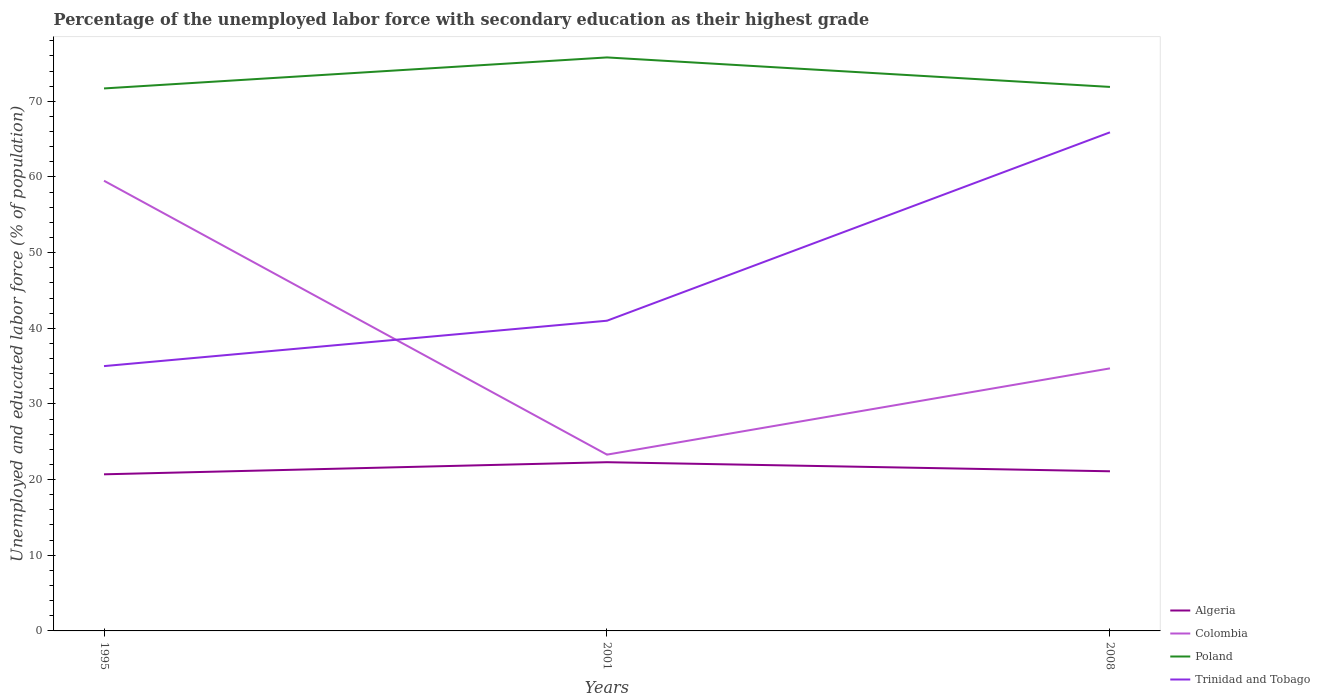Across all years, what is the maximum percentage of the unemployed labor force with secondary education in Colombia?
Give a very brief answer. 23.3. What is the total percentage of the unemployed labor force with secondary education in Trinidad and Tobago in the graph?
Ensure brevity in your answer.  -24.9. What is the difference between the highest and the second highest percentage of the unemployed labor force with secondary education in Colombia?
Provide a short and direct response. 36.2. Are the values on the major ticks of Y-axis written in scientific E-notation?
Your answer should be compact. No. Does the graph contain any zero values?
Offer a terse response. No. Does the graph contain grids?
Offer a terse response. No. Where does the legend appear in the graph?
Make the answer very short. Bottom right. How many legend labels are there?
Ensure brevity in your answer.  4. What is the title of the graph?
Give a very brief answer. Percentage of the unemployed labor force with secondary education as their highest grade. Does "Vanuatu" appear as one of the legend labels in the graph?
Keep it short and to the point. No. What is the label or title of the Y-axis?
Offer a very short reply. Unemployed and educated labor force (% of population). What is the Unemployed and educated labor force (% of population) of Algeria in 1995?
Offer a very short reply. 20.7. What is the Unemployed and educated labor force (% of population) in Colombia in 1995?
Ensure brevity in your answer.  59.5. What is the Unemployed and educated labor force (% of population) in Poland in 1995?
Provide a succinct answer. 71.7. What is the Unemployed and educated labor force (% of population) in Trinidad and Tobago in 1995?
Ensure brevity in your answer.  35. What is the Unemployed and educated labor force (% of population) of Algeria in 2001?
Keep it short and to the point. 22.3. What is the Unemployed and educated labor force (% of population) in Colombia in 2001?
Offer a terse response. 23.3. What is the Unemployed and educated labor force (% of population) of Poland in 2001?
Your answer should be compact. 75.8. What is the Unemployed and educated labor force (% of population) of Algeria in 2008?
Make the answer very short. 21.1. What is the Unemployed and educated labor force (% of population) in Colombia in 2008?
Provide a succinct answer. 34.7. What is the Unemployed and educated labor force (% of population) in Poland in 2008?
Your answer should be very brief. 71.9. What is the Unemployed and educated labor force (% of population) of Trinidad and Tobago in 2008?
Offer a very short reply. 65.9. Across all years, what is the maximum Unemployed and educated labor force (% of population) of Algeria?
Keep it short and to the point. 22.3. Across all years, what is the maximum Unemployed and educated labor force (% of population) of Colombia?
Offer a very short reply. 59.5. Across all years, what is the maximum Unemployed and educated labor force (% of population) in Poland?
Offer a terse response. 75.8. Across all years, what is the maximum Unemployed and educated labor force (% of population) of Trinidad and Tobago?
Give a very brief answer. 65.9. Across all years, what is the minimum Unemployed and educated labor force (% of population) of Algeria?
Your answer should be compact. 20.7. Across all years, what is the minimum Unemployed and educated labor force (% of population) of Colombia?
Offer a terse response. 23.3. Across all years, what is the minimum Unemployed and educated labor force (% of population) of Poland?
Offer a terse response. 71.7. Across all years, what is the minimum Unemployed and educated labor force (% of population) of Trinidad and Tobago?
Provide a short and direct response. 35. What is the total Unemployed and educated labor force (% of population) of Algeria in the graph?
Make the answer very short. 64.1. What is the total Unemployed and educated labor force (% of population) in Colombia in the graph?
Give a very brief answer. 117.5. What is the total Unemployed and educated labor force (% of population) in Poland in the graph?
Ensure brevity in your answer.  219.4. What is the total Unemployed and educated labor force (% of population) in Trinidad and Tobago in the graph?
Provide a short and direct response. 141.9. What is the difference between the Unemployed and educated labor force (% of population) in Colombia in 1995 and that in 2001?
Ensure brevity in your answer.  36.2. What is the difference between the Unemployed and educated labor force (% of population) in Poland in 1995 and that in 2001?
Give a very brief answer. -4.1. What is the difference between the Unemployed and educated labor force (% of population) of Algeria in 1995 and that in 2008?
Provide a succinct answer. -0.4. What is the difference between the Unemployed and educated labor force (% of population) in Colombia in 1995 and that in 2008?
Offer a terse response. 24.8. What is the difference between the Unemployed and educated labor force (% of population) in Poland in 1995 and that in 2008?
Your answer should be compact. -0.2. What is the difference between the Unemployed and educated labor force (% of population) of Trinidad and Tobago in 1995 and that in 2008?
Make the answer very short. -30.9. What is the difference between the Unemployed and educated labor force (% of population) of Poland in 2001 and that in 2008?
Give a very brief answer. 3.9. What is the difference between the Unemployed and educated labor force (% of population) in Trinidad and Tobago in 2001 and that in 2008?
Offer a terse response. -24.9. What is the difference between the Unemployed and educated labor force (% of population) in Algeria in 1995 and the Unemployed and educated labor force (% of population) in Colombia in 2001?
Keep it short and to the point. -2.6. What is the difference between the Unemployed and educated labor force (% of population) of Algeria in 1995 and the Unemployed and educated labor force (% of population) of Poland in 2001?
Provide a succinct answer. -55.1. What is the difference between the Unemployed and educated labor force (% of population) in Algeria in 1995 and the Unemployed and educated labor force (% of population) in Trinidad and Tobago in 2001?
Ensure brevity in your answer.  -20.3. What is the difference between the Unemployed and educated labor force (% of population) of Colombia in 1995 and the Unemployed and educated labor force (% of population) of Poland in 2001?
Provide a short and direct response. -16.3. What is the difference between the Unemployed and educated labor force (% of population) in Colombia in 1995 and the Unemployed and educated labor force (% of population) in Trinidad and Tobago in 2001?
Keep it short and to the point. 18.5. What is the difference between the Unemployed and educated labor force (% of population) in Poland in 1995 and the Unemployed and educated labor force (% of population) in Trinidad and Tobago in 2001?
Offer a terse response. 30.7. What is the difference between the Unemployed and educated labor force (% of population) of Algeria in 1995 and the Unemployed and educated labor force (% of population) of Poland in 2008?
Provide a short and direct response. -51.2. What is the difference between the Unemployed and educated labor force (% of population) in Algeria in 1995 and the Unemployed and educated labor force (% of population) in Trinidad and Tobago in 2008?
Provide a succinct answer. -45.2. What is the difference between the Unemployed and educated labor force (% of population) of Colombia in 1995 and the Unemployed and educated labor force (% of population) of Poland in 2008?
Keep it short and to the point. -12.4. What is the difference between the Unemployed and educated labor force (% of population) in Colombia in 1995 and the Unemployed and educated labor force (% of population) in Trinidad and Tobago in 2008?
Provide a succinct answer. -6.4. What is the difference between the Unemployed and educated labor force (% of population) in Poland in 1995 and the Unemployed and educated labor force (% of population) in Trinidad and Tobago in 2008?
Your response must be concise. 5.8. What is the difference between the Unemployed and educated labor force (% of population) in Algeria in 2001 and the Unemployed and educated labor force (% of population) in Colombia in 2008?
Offer a very short reply. -12.4. What is the difference between the Unemployed and educated labor force (% of population) of Algeria in 2001 and the Unemployed and educated labor force (% of population) of Poland in 2008?
Offer a terse response. -49.6. What is the difference between the Unemployed and educated labor force (% of population) in Algeria in 2001 and the Unemployed and educated labor force (% of population) in Trinidad and Tobago in 2008?
Your answer should be very brief. -43.6. What is the difference between the Unemployed and educated labor force (% of population) of Colombia in 2001 and the Unemployed and educated labor force (% of population) of Poland in 2008?
Offer a very short reply. -48.6. What is the difference between the Unemployed and educated labor force (% of population) of Colombia in 2001 and the Unemployed and educated labor force (% of population) of Trinidad and Tobago in 2008?
Ensure brevity in your answer.  -42.6. What is the difference between the Unemployed and educated labor force (% of population) of Poland in 2001 and the Unemployed and educated labor force (% of population) of Trinidad and Tobago in 2008?
Provide a short and direct response. 9.9. What is the average Unemployed and educated labor force (% of population) of Algeria per year?
Your answer should be very brief. 21.37. What is the average Unemployed and educated labor force (% of population) of Colombia per year?
Keep it short and to the point. 39.17. What is the average Unemployed and educated labor force (% of population) in Poland per year?
Ensure brevity in your answer.  73.13. What is the average Unemployed and educated labor force (% of population) in Trinidad and Tobago per year?
Keep it short and to the point. 47.3. In the year 1995, what is the difference between the Unemployed and educated labor force (% of population) in Algeria and Unemployed and educated labor force (% of population) in Colombia?
Ensure brevity in your answer.  -38.8. In the year 1995, what is the difference between the Unemployed and educated labor force (% of population) of Algeria and Unemployed and educated labor force (% of population) of Poland?
Provide a succinct answer. -51. In the year 1995, what is the difference between the Unemployed and educated labor force (% of population) of Algeria and Unemployed and educated labor force (% of population) of Trinidad and Tobago?
Keep it short and to the point. -14.3. In the year 1995, what is the difference between the Unemployed and educated labor force (% of population) in Colombia and Unemployed and educated labor force (% of population) in Poland?
Provide a short and direct response. -12.2. In the year 1995, what is the difference between the Unemployed and educated labor force (% of population) of Poland and Unemployed and educated labor force (% of population) of Trinidad and Tobago?
Provide a short and direct response. 36.7. In the year 2001, what is the difference between the Unemployed and educated labor force (% of population) of Algeria and Unemployed and educated labor force (% of population) of Colombia?
Provide a succinct answer. -1. In the year 2001, what is the difference between the Unemployed and educated labor force (% of population) in Algeria and Unemployed and educated labor force (% of population) in Poland?
Offer a very short reply. -53.5. In the year 2001, what is the difference between the Unemployed and educated labor force (% of population) of Algeria and Unemployed and educated labor force (% of population) of Trinidad and Tobago?
Ensure brevity in your answer.  -18.7. In the year 2001, what is the difference between the Unemployed and educated labor force (% of population) of Colombia and Unemployed and educated labor force (% of population) of Poland?
Your response must be concise. -52.5. In the year 2001, what is the difference between the Unemployed and educated labor force (% of population) in Colombia and Unemployed and educated labor force (% of population) in Trinidad and Tobago?
Offer a very short reply. -17.7. In the year 2001, what is the difference between the Unemployed and educated labor force (% of population) of Poland and Unemployed and educated labor force (% of population) of Trinidad and Tobago?
Keep it short and to the point. 34.8. In the year 2008, what is the difference between the Unemployed and educated labor force (% of population) in Algeria and Unemployed and educated labor force (% of population) in Colombia?
Make the answer very short. -13.6. In the year 2008, what is the difference between the Unemployed and educated labor force (% of population) in Algeria and Unemployed and educated labor force (% of population) in Poland?
Offer a terse response. -50.8. In the year 2008, what is the difference between the Unemployed and educated labor force (% of population) in Algeria and Unemployed and educated labor force (% of population) in Trinidad and Tobago?
Offer a terse response. -44.8. In the year 2008, what is the difference between the Unemployed and educated labor force (% of population) in Colombia and Unemployed and educated labor force (% of population) in Poland?
Give a very brief answer. -37.2. In the year 2008, what is the difference between the Unemployed and educated labor force (% of population) in Colombia and Unemployed and educated labor force (% of population) in Trinidad and Tobago?
Offer a terse response. -31.2. In the year 2008, what is the difference between the Unemployed and educated labor force (% of population) of Poland and Unemployed and educated labor force (% of population) of Trinidad and Tobago?
Provide a succinct answer. 6. What is the ratio of the Unemployed and educated labor force (% of population) of Algeria in 1995 to that in 2001?
Your answer should be compact. 0.93. What is the ratio of the Unemployed and educated labor force (% of population) in Colombia in 1995 to that in 2001?
Provide a succinct answer. 2.55. What is the ratio of the Unemployed and educated labor force (% of population) in Poland in 1995 to that in 2001?
Provide a succinct answer. 0.95. What is the ratio of the Unemployed and educated labor force (% of population) of Trinidad and Tobago in 1995 to that in 2001?
Ensure brevity in your answer.  0.85. What is the ratio of the Unemployed and educated labor force (% of population) in Algeria in 1995 to that in 2008?
Offer a terse response. 0.98. What is the ratio of the Unemployed and educated labor force (% of population) of Colombia in 1995 to that in 2008?
Give a very brief answer. 1.71. What is the ratio of the Unemployed and educated labor force (% of population) of Poland in 1995 to that in 2008?
Give a very brief answer. 1. What is the ratio of the Unemployed and educated labor force (% of population) of Trinidad and Tobago in 1995 to that in 2008?
Make the answer very short. 0.53. What is the ratio of the Unemployed and educated labor force (% of population) in Algeria in 2001 to that in 2008?
Give a very brief answer. 1.06. What is the ratio of the Unemployed and educated labor force (% of population) in Colombia in 2001 to that in 2008?
Offer a terse response. 0.67. What is the ratio of the Unemployed and educated labor force (% of population) of Poland in 2001 to that in 2008?
Your answer should be very brief. 1.05. What is the ratio of the Unemployed and educated labor force (% of population) in Trinidad and Tobago in 2001 to that in 2008?
Your response must be concise. 0.62. What is the difference between the highest and the second highest Unemployed and educated labor force (% of population) of Colombia?
Your answer should be compact. 24.8. What is the difference between the highest and the second highest Unemployed and educated labor force (% of population) in Trinidad and Tobago?
Make the answer very short. 24.9. What is the difference between the highest and the lowest Unemployed and educated labor force (% of population) of Colombia?
Give a very brief answer. 36.2. What is the difference between the highest and the lowest Unemployed and educated labor force (% of population) of Trinidad and Tobago?
Your answer should be very brief. 30.9. 